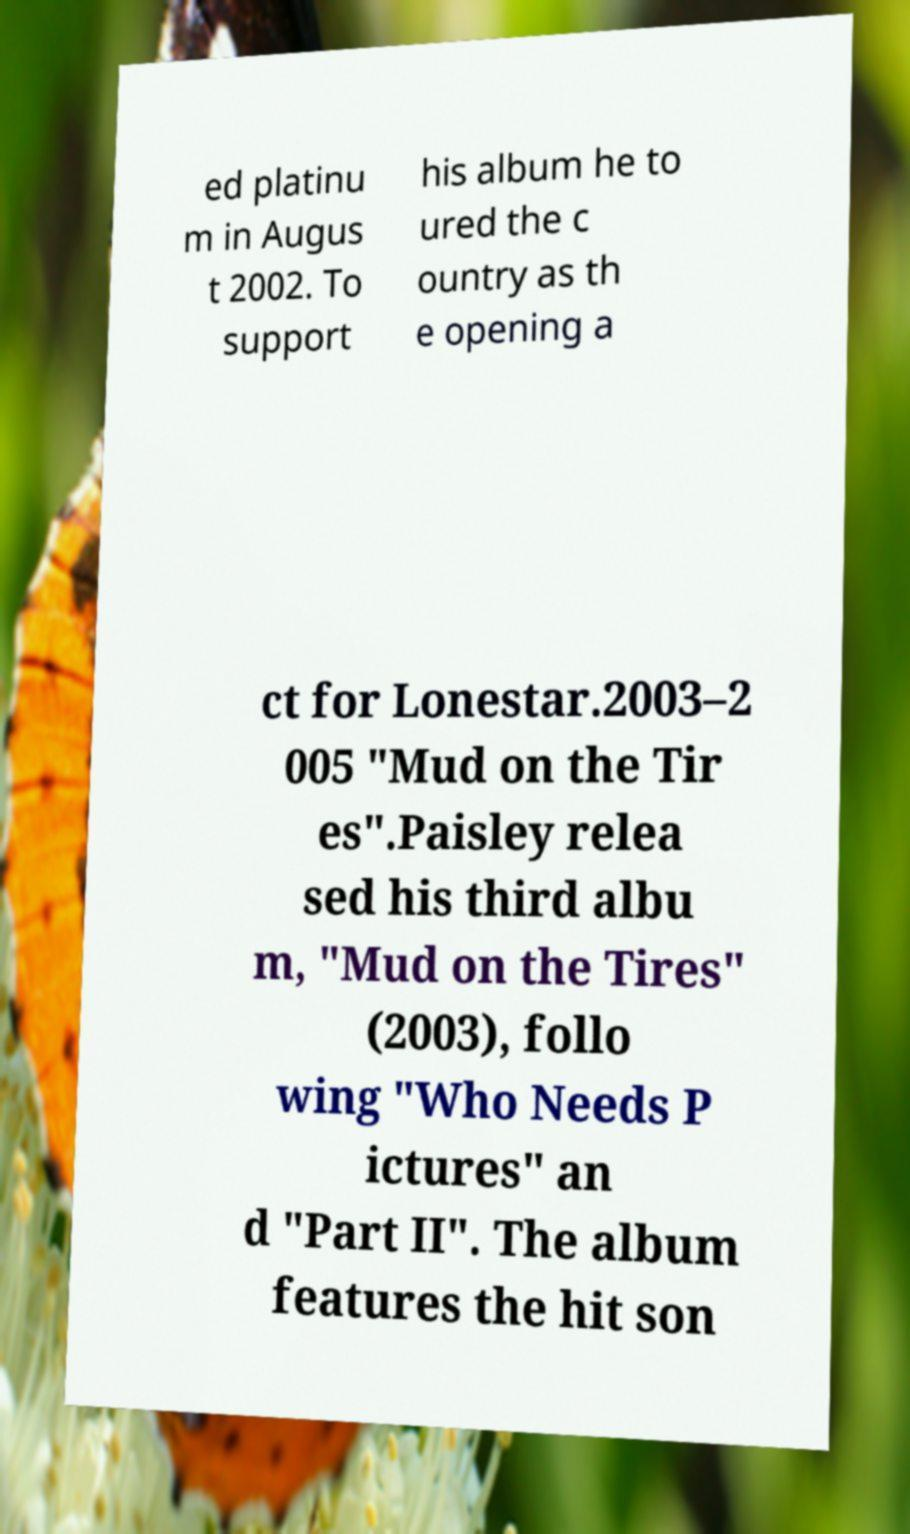Can you accurately transcribe the text from the provided image for me? ed platinu m in Augus t 2002. To support his album he to ured the c ountry as th e opening a ct for Lonestar.2003–2 005 "Mud on the Tir es".Paisley relea sed his third albu m, "Mud on the Tires" (2003), follo wing "Who Needs P ictures" an d "Part II". The album features the hit son 